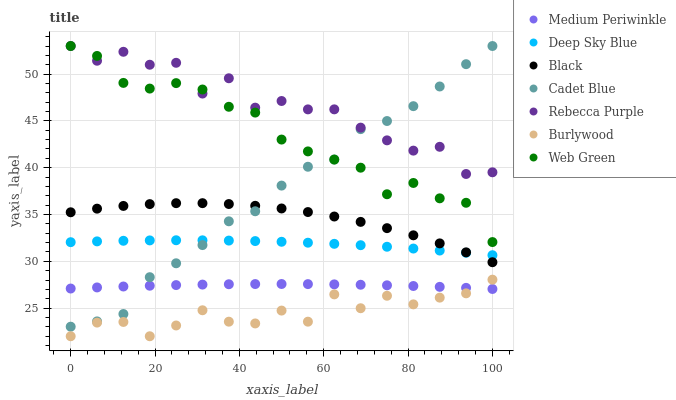Does Burlywood have the minimum area under the curve?
Answer yes or no. Yes. Does Rebecca Purple have the maximum area under the curve?
Answer yes or no. Yes. Does Medium Periwinkle have the minimum area under the curve?
Answer yes or no. No. Does Medium Periwinkle have the maximum area under the curve?
Answer yes or no. No. Is Medium Periwinkle the smoothest?
Answer yes or no. Yes. Is Rebecca Purple the roughest?
Answer yes or no. Yes. Is Burlywood the smoothest?
Answer yes or no. No. Is Burlywood the roughest?
Answer yes or no. No. Does Burlywood have the lowest value?
Answer yes or no. Yes. Does Medium Periwinkle have the lowest value?
Answer yes or no. No. Does Rebecca Purple have the highest value?
Answer yes or no. Yes. Does Burlywood have the highest value?
Answer yes or no. No. Is Deep Sky Blue less than Web Green?
Answer yes or no. Yes. Is Rebecca Purple greater than Burlywood?
Answer yes or no. Yes. Does Rebecca Purple intersect Cadet Blue?
Answer yes or no. Yes. Is Rebecca Purple less than Cadet Blue?
Answer yes or no. No. Is Rebecca Purple greater than Cadet Blue?
Answer yes or no. No. Does Deep Sky Blue intersect Web Green?
Answer yes or no. No. 